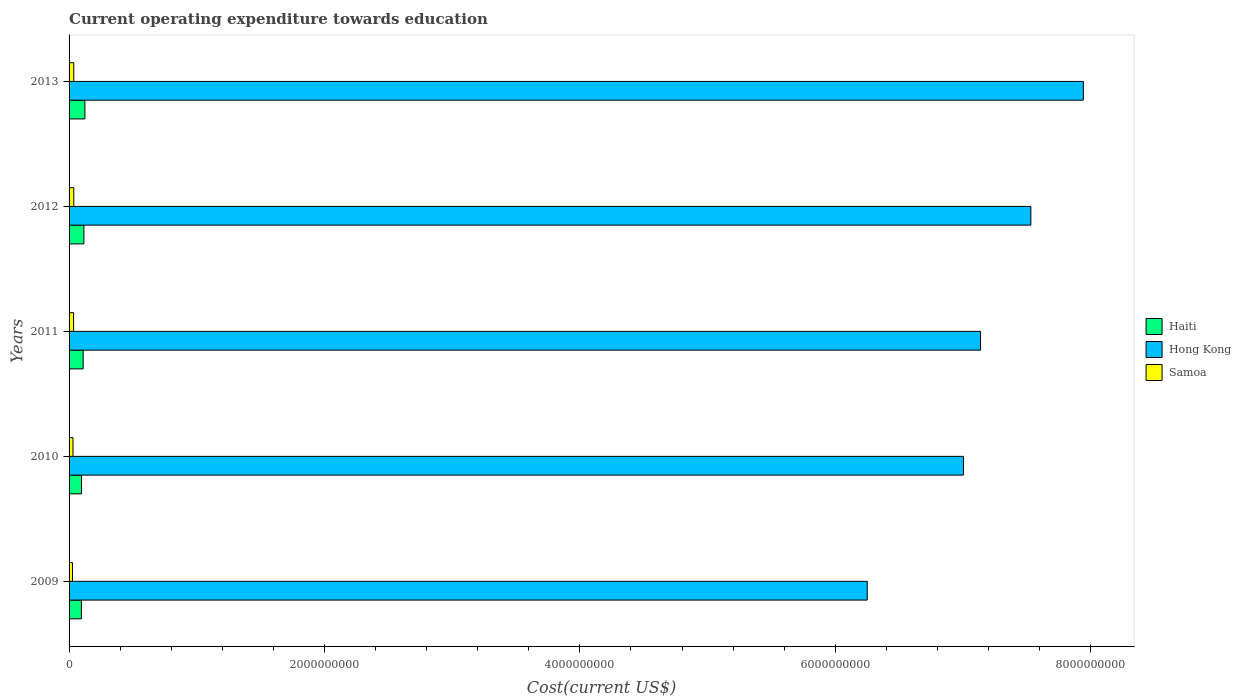How many different coloured bars are there?
Offer a terse response. 3. How many groups of bars are there?
Make the answer very short. 5. Are the number of bars per tick equal to the number of legend labels?
Make the answer very short. Yes. How many bars are there on the 3rd tick from the top?
Your answer should be very brief. 3. In how many cases, is the number of bars for a given year not equal to the number of legend labels?
Your answer should be compact. 0. What is the expenditure towards education in Hong Kong in 2010?
Make the answer very short. 7.00e+09. Across all years, what is the maximum expenditure towards education in Hong Kong?
Make the answer very short. 7.94e+09. Across all years, what is the minimum expenditure towards education in Hong Kong?
Make the answer very short. 6.25e+09. In which year was the expenditure towards education in Haiti maximum?
Offer a very short reply. 2013. What is the total expenditure towards education in Samoa in the graph?
Give a very brief answer. 1.66e+08. What is the difference between the expenditure towards education in Samoa in 2010 and that in 2013?
Provide a short and direct response. -6.12e+06. What is the difference between the expenditure towards education in Haiti in 2009 and the expenditure towards education in Hong Kong in 2012?
Give a very brief answer. -7.44e+09. What is the average expenditure towards education in Hong Kong per year?
Provide a short and direct response. 7.17e+09. In the year 2010, what is the difference between the expenditure towards education in Hong Kong and expenditure towards education in Samoa?
Ensure brevity in your answer.  6.97e+09. In how many years, is the expenditure towards education in Haiti greater than 3600000000 US$?
Your answer should be very brief. 0. What is the ratio of the expenditure towards education in Samoa in 2010 to that in 2013?
Provide a succinct answer. 0.83. What is the difference between the highest and the second highest expenditure towards education in Hong Kong?
Make the answer very short. 4.11e+08. What is the difference between the highest and the lowest expenditure towards education in Haiti?
Offer a terse response. 2.76e+07. Is the sum of the expenditure towards education in Hong Kong in 2010 and 2011 greater than the maximum expenditure towards education in Haiti across all years?
Your answer should be very brief. Yes. What does the 3rd bar from the top in 2012 represents?
Provide a succinct answer. Haiti. What does the 3rd bar from the bottom in 2009 represents?
Provide a short and direct response. Samoa. Is it the case that in every year, the sum of the expenditure towards education in Samoa and expenditure towards education in Hong Kong is greater than the expenditure towards education in Haiti?
Give a very brief answer. Yes. How many bars are there?
Provide a succinct answer. 15. How many years are there in the graph?
Offer a terse response. 5. What is the difference between two consecutive major ticks on the X-axis?
Offer a terse response. 2.00e+09. Does the graph contain any zero values?
Your answer should be compact. No. Where does the legend appear in the graph?
Give a very brief answer. Center right. What is the title of the graph?
Provide a succinct answer. Current operating expenditure towards education. Does "Kazakhstan" appear as one of the legend labels in the graph?
Ensure brevity in your answer.  No. What is the label or title of the X-axis?
Offer a terse response. Cost(current US$). What is the label or title of the Y-axis?
Provide a succinct answer. Years. What is the Cost(current US$) of Haiti in 2009?
Give a very brief answer. 9.64e+07. What is the Cost(current US$) in Hong Kong in 2009?
Your answer should be very brief. 6.25e+09. What is the Cost(current US$) in Samoa in 2009?
Your answer should be compact. 2.66e+07. What is the Cost(current US$) in Haiti in 2010?
Ensure brevity in your answer.  9.71e+07. What is the Cost(current US$) of Hong Kong in 2010?
Provide a short and direct response. 7.00e+09. What is the Cost(current US$) of Samoa in 2010?
Provide a short and direct response. 3.05e+07. What is the Cost(current US$) of Haiti in 2011?
Provide a short and direct response. 1.10e+08. What is the Cost(current US$) of Hong Kong in 2011?
Give a very brief answer. 7.14e+09. What is the Cost(current US$) of Samoa in 2011?
Give a very brief answer. 3.53e+07. What is the Cost(current US$) in Haiti in 2012?
Make the answer very short. 1.16e+08. What is the Cost(current US$) in Hong Kong in 2012?
Provide a succinct answer. 7.53e+09. What is the Cost(current US$) of Samoa in 2012?
Your answer should be very brief. 3.68e+07. What is the Cost(current US$) in Haiti in 2013?
Provide a succinct answer. 1.24e+08. What is the Cost(current US$) of Hong Kong in 2013?
Keep it short and to the point. 7.94e+09. What is the Cost(current US$) in Samoa in 2013?
Your response must be concise. 3.66e+07. Across all years, what is the maximum Cost(current US$) in Haiti?
Provide a succinct answer. 1.24e+08. Across all years, what is the maximum Cost(current US$) of Hong Kong?
Provide a succinct answer. 7.94e+09. Across all years, what is the maximum Cost(current US$) of Samoa?
Your answer should be compact. 3.68e+07. Across all years, what is the minimum Cost(current US$) in Haiti?
Provide a succinct answer. 9.64e+07. Across all years, what is the minimum Cost(current US$) in Hong Kong?
Your answer should be compact. 6.25e+09. Across all years, what is the minimum Cost(current US$) of Samoa?
Your answer should be compact. 2.66e+07. What is the total Cost(current US$) of Haiti in the graph?
Provide a succinct answer. 5.44e+08. What is the total Cost(current US$) of Hong Kong in the graph?
Your response must be concise. 3.59e+1. What is the total Cost(current US$) of Samoa in the graph?
Provide a short and direct response. 1.66e+08. What is the difference between the Cost(current US$) of Haiti in 2009 and that in 2010?
Your answer should be very brief. -6.92e+05. What is the difference between the Cost(current US$) in Hong Kong in 2009 and that in 2010?
Your response must be concise. -7.54e+08. What is the difference between the Cost(current US$) in Samoa in 2009 and that in 2010?
Offer a terse response. -3.92e+06. What is the difference between the Cost(current US$) of Haiti in 2009 and that in 2011?
Make the answer very short. -1.40e+07. What is the difference between the Cost(current US$) in Hong Kong in 2009 and that in 2011?
Your answer should be very brief. -8.87e+08. What is the difference between the Cost(current US$) of Samoa in 2009 and that in 2011?
Make the answer very short. -8.68e+06. What is the difference between the Cost(current US$) of Haiti in 2009 and that in 2012?
Give a very brief answer. -1.97e+07. What is the difference between the Cost(current US$) in Hong Kong in 2009 and that in 2012?
Your response must be concise. -1.28e+09. What is the difference between the Cost(current US$) in Samoa in 2009 and that in 2012?
Provide a succinct answer. -1.02e+07. What is the difference between the Cost(current US$) of Haiti in 2009 and that in 2013?
Ensure brevity in your answer.  -2.76e+07. What is the difference between the Cost(current US$) of Hong Kong in 2009 and that in 2013?
Give a very brief answer. -1.69e+09. What is the difference between the Cost(current US$) in Samoa in 2009 and that in 2013?
Offer a very short reply. -1.00e+07. What is the difference between the Cost(current US$) in Haiti in 2010 and that in 2011?
Provide a succinct answer. -1.33e+07. What is the difference between the Cost(current US$) in Hong Kong in 2010 and that in 2011?
Offer a terse response. -1.34e+08. What is the difference between the Cost(current US$) in Samoa in 2010 and that in 2011?
Your response must be concise. -4.76e+06. What is the difference between the Cost(current US$) in Haiti in 2010 and that in 2012?
Keep it short and to the point. -1.90e+07. What is the difference between the Cost(current US$) of Hong Kong in 2010 and that in 2012?
Your answer should be very brief. -5.28e+08. What is the difference between the Cost(current US$) in Samoa in 2010 and that in 2012?
Offer a terse response. -6.32e+06. What is the difference between the Cost(current US$) of Haiti in 2010 and that in 2013?
Your response must be concise. -2.69e+07. What is the difference between the Cost(current US$) of Hong Kong in 2010 and that in 2013?
Give a very brief answer. -9.39e+08. What is the difference between the Cost(current US$) in Samoa in 2010 and that in 2013?
Make the answer very short. -6.12e+06. What is the difference between the Cost(current US$) of Haiti in 2011 and that in 2012?
Give a very brief answer. -5.70e+06. What is the difference between the Cost(current US$) in Hong Kong in 2011 and that in 2012?
Keep it short and to the point. -3.94e+08. What is the difference between the Cost(current US$) of Samoa in 2011 and that in 2012?
Keep it short and to the point. -1.56e+06. What is the difference between the Cost(current US$) of Haiti in 2011 and that in 2013?
Ensure brevity in your answer.  -1.36e+07. What is the difference between the Cost(current US$) of Hong Kong in 2011 and that in 2013?
Offer a very short reply. -8.05e+08. What is the difference between the Cost(current US$) in Samoa in 2011 and that in 2013?
Provide a short and direct response. -1.36e+06. What is the difference between the Cost(current US$) in Haiti in 2012 and that in 2013?
Provide a short and direct response. -7.89e+06. What is the difference between the Cost(current US$) in Hong Kong in 2012 and that in 2013?
Provide a short and direct response. -4.11e+08. What is the difference between the Cost(current US$) in Samoa in 2012 and that in 2013?
Your answer should be compact. 2.06e+05. What is the difference between the Cost(current US$) of Haiti in 2009 and the Cost(current US$) of Hong Kong in 2010?
Keep it short and to the point. -6.91e+09. What is the difference between the Cost(current US$) of Haiti in 2009 and the Cost(current US$) of Samoa in 2010?
Offer a very short reply. 6.59e+07. What is the difference between the Cost(current US$) of Hong Kong in 2009 and the Cost(current US$) of Samoa in 2010?
Make the answer very short. 6.22e+09. What is the difference between the Cost(current US$) of Haiti in 2009 and the Cost(current US$) of Hong Kong in 2011?
Make the answer very short. -7.04e+09. What is the difference between the Cost(current US$) in Haiti in 2009 and the Cost(current US$) in Samoa in 2011?
Give a very brief answer. 6.12e+07. What is the difference between the Cost(current US$) of Hong Kong in 2009 and the Cost(current US$) of Samoa in 2011?
Make the answer very short. 6.22e+09. What is the difference between the Cost(current US$) of Haiti in 2009 and the Cost(current US$) of Hong Kong in 2012?
Ensure brevity in your answer.  -7.44e+09. What is the difference between the Cost(current US$) in Haiti in 2009 and the Cost(current US$) in Samoa in 2012?
Provide a succinct answer. 5.96e+07. What is the difference between the Cost(current US$) of Hong Kong in 2009 and the Cost(current US$) of Samoa in 2012?
Provide a short and direct response. 6.21e+09. What is the difference between the Cost(current US$) in Haiti in 2009 and the Cost(current US$) in Hong Kong in 2013?
Your response must be concise. -7.85e+09. What is the difference between the Cost(current US$) of Haiti in 2009 and the Cost(current US$) of Samoa in 2013?
Keep it short and to the point. 5.98e+07. What is the difference between the Cost(current US$) in Hong Kong in 2009 and the Cost(current US$) in Samoa in 2013?
Your response must be concise. 6.21e+09. What is the difference between the Cost(current US$) in Haiti in 2010 and the Cost(current US$) in Hong Kong in 2011?
Give a very brief answer. -7.04e+09. What is the difference between the Cost(current US$) of Haiti in 2010 and the Cost(current US$) of Samoa in 2011?
Give a very brief answer. 6.19e+07. What is the difference between the Cost(current US$) of Hong Kong in 2010 and the Cost(current US$) of Samoa in 2011?
Keep it short and to the point. 6.97e+09. What is the difference between the Cost(current US$) in Haiti in 2010 and the Cost(current US$) in Hong Kong in 2012?
Ensure brevity in your answer.  -7.43e+09. What is the difference between the Cost(current US$) in Haiti in 2010 and the Cost(current US$) in Samoa in 2012?
Your answer should be very brief. 6.03e+07. What is the difference between the Cost(current US$) of Hong Kong in 2010 and the Cost(current US$) of Samoa in 2012?
Ensure brevity in your answer.  6.97e+09. What is the difference between the Cost(current US$) in Haiti in 2010 and the Cost(current US$) in Hong Kong in 2013?
Keep it short and to the point. -7.85e+09. What is the difference between the Cost(current US$) of Haiti in 2010 and the Cost(current US$) of Samoa in 2013?
Provide a short and direct response. 6.05e+07. What is the difference between the Cost(current US$) of Hong Kong in 2010 and the Cost(current US$) of Samoa in 2013?
Your response must be concise. 6.97e+09. What is the difference between the Cost(current US$) of Haiti in 2011 and the Cost(current US$) of Hong Kong in 2012?
Your answer should be very brief. -7.42e+09. What is the difference between the Cost(current US$) in Haiti in 2011 and the Cost(current US$) in Samoa in 2012?
Provide a succinct answer. 7.36e+07. What is the difference between the Cost(current US$) of Hong Kong in 2011 and the Cost(current US$) of Samoa in 2012?
Make the answer very short. 7.10e+09. What is the difference between the Cost(current US$) in Haiti in 2011 and the Cost(current US$) in Hong Kong in 2013?
Give a very brief answer. -7.83e+09. What is the difference between the Cost(current US$) of Haiti in 2011 and the Cost(current US$) of Samoa in 2013?
Ensure brevity in your answer.  7.38e+07. What is the difference between the Cost(current US$) of Hong Kong in 2011 and the Cost(current US$) of Samoa in 2013?
Offer a very short reply. 7.10e+09. What is the difference between the Cost(current US$) of Haiti in 2012 and the Cost(current US$) of Hong Kong in 2013?
Make the answer very short. -7.83e+09. What is the difference between the Cost(current US$) of Haiti in 2012 and the Cost(current US$) of Samoa in 2013?
Offer a terse response. 7.95e+07. What is the difference between the Cost(current US$) of Hong Kong in 2012 and the Cost(current US$) of Samoa in 2013?
Give a very brief answer. 7.50e+09. What is the average Cost(current US$) of Haiti per year?
Keep it short and to the point. 1.09e+08. What is the average Cost(current US$) of Hong Kong per year?
Make the answer very short. 7.17e+09. What is the average Cost(current US$) of Samoa per year?
Your answer should be compact. 3.32e+07. In the year 2009, what is the difference between the Cost(current US$) of Haiti and Cost(current US$) of Hong Kong?
Make the answer very short. -6.15e+09. In the year 2009, what is the difference between the Cost(current US$) in Haiti and Cost(current US$) in Samoa?
Ensure brevity in your answer.  6.98e+07. In the year 2009, what is the difference between the Cost(current US$) of Hong Kong and Cost(current US$) of Samoa?
Provide a succinct answer. 6.22e+09. In the year 2010, what is the difference between the Cost(current US$) in Haiti and Cost(current US$) in Hong Kong?
Offer a terse response. -6.91e+09. In the year 2010, what is the difference between the Cost(current US$) in Haiti and Cost(current US$) in Samoa?
Ensure brevity in your answer.  6.66e+07. In the year 2010, what is the difference between the Cost(current US$) in Hong Kong and Cost(current US$) in Samoa?
Provide a short and direct response. 6.97e+09. In the year 2011, what is the difference between the Cost(current US$) in Haiti and Cost(current US$) in Hong Kong?
Your response must be concise. -7.03e+09. In the year 2011, what is the difference between the Cost(current US$) in Haiti and Cost(current US$) in Samoa?
Keep it short and to the point. 7.51e+07. In the year 2011, what is the difference between the Cost(current US$) of Hong Kong and Cost(current US$) of Samoa?
Ensure brevity in your answer.  7.10e+09. In the year 2012, what is the difference between the Cost(current US$) of Haiti and Cost(current US$) of Hong Kong?
Your response must be concise. -7.42e+09. In the year 2012, what is the difference between the Cost(current US$) of Haiti and Cost(current US$) of Samoa?
Your answer should be compact. 7.93e+07. In the year 2012, what is the difference between the Cost(current US$) in Hong Kong and Cost(current US$) in Samoa?
Your answer should be very brief. 7.50e+09. In the year 2013, what is the difference between the Cost(current US$) of Haiti and Cost(current US$) of Hong Kong?
Provide a short and direct response. -7.82e+09. In the year 2013, what is the difference between the Cost(current US$) of Haiti and Cost(current US$) of Samoa?
Ensure brevity in your answer.  8.74e+07. In the year 2013, what is the difference between the Cost(current US$) in Hong Kong and Cost(current US$) in Samoa?
Your answer should be very brief. 7.91e+09. What is the ratio of the Cost(current US$) in Hong Kong in 2009 to that in 2010?
Offer a terse response. 0.89. What is the ratio of the Cost(current US$) in Samoa in 2009 to that in 2010?
Offer a terse response. 0.87. What is the ratio of the Cost(current US$) in Haiti in 2009 to that in 2011?
Give a very brief answer. 0.87. What is the ratio of the Cost(current US$) of Hong Kong in 2009 to that in 2011?
Offer a terse response. 0.88. What is the ratio of the Cost(current US$) of Samoa in 2009 to that in 2011?
Your answer should be compact. 0.75. What is the ratio of the Cost(current US$) in Haiti in 2009 to that in 2012?
Your answer should be very brief. 0.83. What is the ratio of the Cost(current US$) in Hong Kong in 2009 to that in 2012?
Offer a very short reply. 0.83. What is the ratio of the Cost(current US$) of Samoa in 2009 to that in 2012?
Ensure brevity in your answer.  0.72. What is the ratio of the Cost(current US$) in Haiti in 2009 to that in 2013?
Make the answer very short. 0.78. What is the ratio of the Cost(current US$) in Hong Kong in 2009 to that in 2013?
Ensure brevity in your answer.  0.79. What is the ratio of the Cost(current US$) in Samoa in 2009 to that in 2013?
Provide a short and direct response. 0.73. What is the ratio of the Cost(current US$) of Haiti in 2010 to that in 2011?
Ensure brevity in your answer.  0.88. What is the ratio of the Cost(current US$) in Hong Kong in 2010 to that in 2011?
Keep it short and to the point. 0.98. What is the ratio of the Cost(current US$) in Samoa in 2010 to that in 2011?
Ensure brevity in your answer.  0.87. What is the ratio of the Cost(current US$) of Haiti in 2010 to that in 2012?
Give a very brief answer. 0.84. What is the ratio of the Cost(current US$) of Hong Kong in 2010 to that in 2012?
Offer a terse response. 0.93. What is the ratio of the Cost(current US$) in Samoa in 2010 to that in 2012?
Offer a very short reply. 0.83. What is the ratio of the Cost(current US$) in Haiti in 2010 to that in 2013?
Offer a terse response. 0.78. What is the ratio of the Cost(current US$) in Hong Kong in 2010 to that in 2013?
Your answer should be very brief. 0.88. What is the ratio of the Cost(current US$) of Samoa in 2010 to that in 2013?
Offer a terse response. 0.83. What is the ratio of the Cost(current US$) of Haiti in 2011 to that in 2012?
Give a very brief answer. 0.95. What is the ratio of the Cost(current US$) of Hong Kong in 2011 to that in 2012?
Provide a succinct answer. 0.95. What is the ratio of the Cost(current US$) of Samoa in 2011 to that in 2012?
Ensure brevity in your answer.  0.96. What is the ratio of the Cost(current US$) of Haiti in 2011 to that in 2013?
Provide a short and direct response. 0.89. What is the ratio of the Cost(current US$) of Hong Kong in 2011 to that in 2013?
Offer a very short reply. 0.9. What is the ratio of the Cost(current US$) of Samoa in 2011 to that in 2013?
Your answer should be very brief. 0.96. What is the ratio of the Cost(current US$) in Haiti in 2012 to that in 2013?
Offer a terse response. 0.94. What is the ratio of the Cost(current US$) in Hong Kong in 2012 to that in 2013?
Offer a very short reply. 0.95. What is the ratio of the Cost(current US$) in Samoa in 2012 to that in 2013?
Keep it short and to the point. 1.01. What is the difference between the highest and the second highest Cost(current US$) of Haiti?
Your answer should be very brief. 7.89e+06. What is the difference between the highest and the second highest Cost(current US$) of Hong Kong?
Your answer should be very brief. 4.11e+08. What is the difference between the highest and the second highest Cost(current US$) in Samoa?
Keep it short and to the point. 2.06e+05. What is the difference between the highest and the lowest Cost(current US$) of Haiti?
Your answer should be compact. 2.76e+07. What is the difference between the highest and the lowest Cost(current US$) in Hong Kong?
Provide a succinct answer. 1.69e+09. What is the difference between the highest and the lowest Cost(current US$) in Samoa?
Make the answer very short. 1.02e+07. 